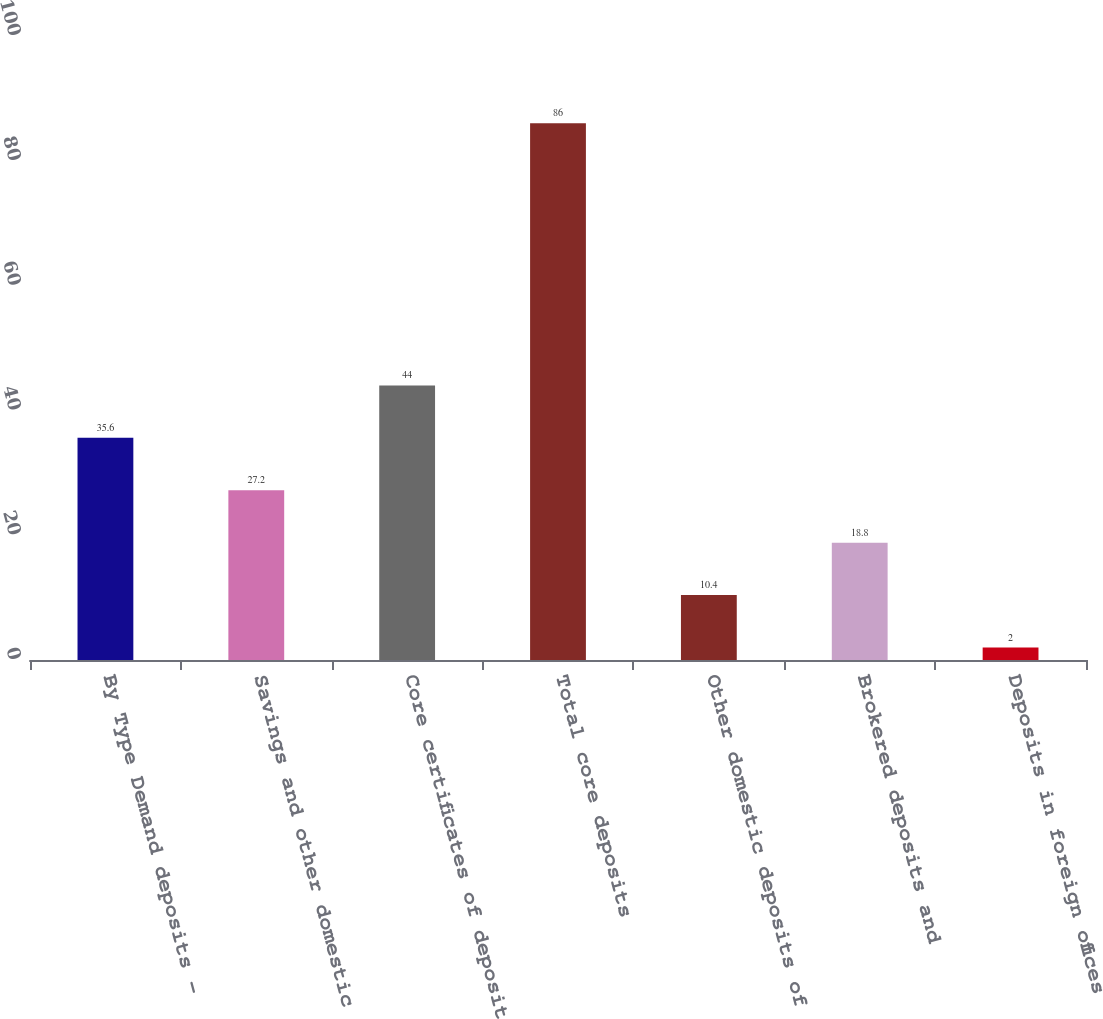Convert chart. <chart><loc_0><loc_0><loc_500><loc_500><bar_chart><fcel>By Type Demand deposits -<fcel>Savings and other domestic<fcel>Core certificates of deposit<fcel>Total core deposits<fcel>Other domestic deposits of<fcel>Brokered deposits and<fcel>Deposits in foreign offices<nl><fcel>35.6<fcel>27.2<fcel>44<fcel>86<fcel>10.4<fcel>18.8<fcel>2<nl></chart> 